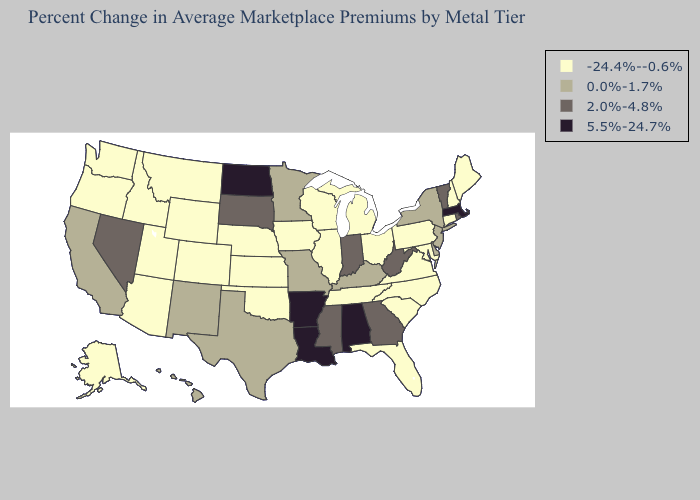Does Georgia have the lowest value in the South?
Keep it brief. No. Which states have the lowest value in the USA?
Answer briefly. Alaska, Arizona, Colorado, Connecticut, Florida, Idaho, Illinois, Iowa, Kansas, Maine, Maryland, Michigan, Montana, Nebraska, New Hampshire, North Carolina, Ohio, Oklahoma, Oregon, Pennsylvania, South Carolina, Tennessee, Utah, Virginia, Washington, Wisconsin, Wyoming. Does the map have missing data?
Short answer required. No. Name the states that have a value in the range 5.5%-24.7%?
Write a very short answer. Alabama, Arkansas, Louisiana, Massachusetts, North Dakota. Name the states that have a value in the range 0.0%-1.7%?
Write a very short answer. California, Delaware, Hawaii, Kentucky, Minnesota, Missouri, New Jersey, New Mexico, New York, Texas. What is the value of Colorado?
Short answer required. -24.4%--0.6%. What is the value of Wisconsin?
Be succinct. -24.4%--0.6%. Which states have the highest value in the USA?
Answer briefly. Alabama, Arkansas, Louisiana, Massachusetts, North Dakota. What is the value of Connecticut?
Keep it brief. -24.4%--0.6%. Does Kansas have the same value as Georgia?
Short answer required. No. What is the highest value in the USA?
Short answer required. 5.5%-24.7%. Does South Dakota have a higher value than Maine?
Concise answer only. Yes. What is the value of Colorado?
Quick response, please. -24.4%--0.6%. Is the legend a continuous bar?
Keep it brief. No. Which states have the highest value in the USA?
Concise answer only. Alabama, Arkansas, Louisiana, Massachusetts, North Dakota. 